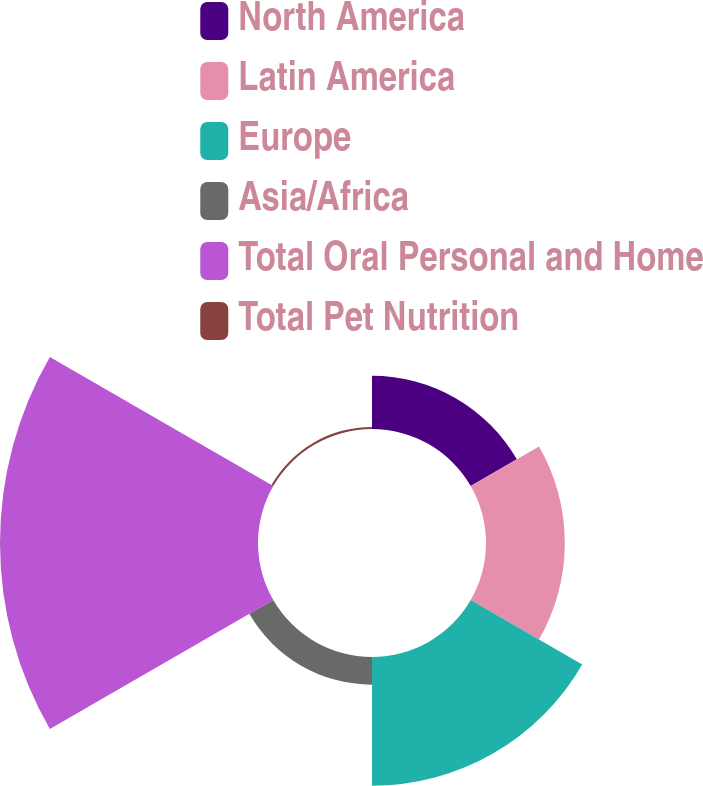<chart> <loc_0><loc_0><loc_500><loc_500><pie_chart><fcel>North America<fcel>Latin America<fcel>Europe<fcel>Asia/Africa<fcel>Total Oral Personal and Home<fcel>Total Pet Nutrition<nl><fcel>9.71%<fcel>14.37%<fcel>23.47%<fcel>5.04%<fcel>47.03%<fcel>0.38%<nl></chart> 